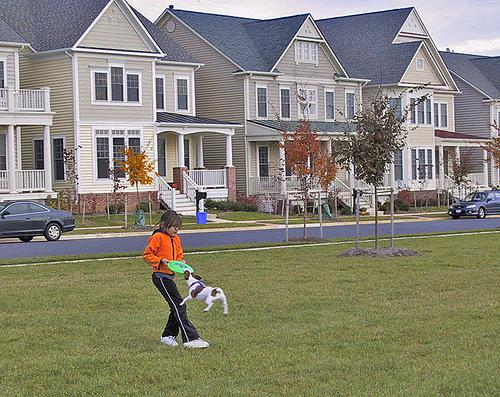Question: where are the dog and girl playing?
Choices:
A. Across the street from row houses.
B. In a field.
C. In a park.
D. Far away.
Answer with the letter. Answer: A Question: when was this image taken?
Choices:
A. Daytime.
B. Before nightfall.
C. During field day.
D. Morning or afternoon.
Answer with the letter. Answer: D Question: why is the dog jumping at this person?
Choices:
A. A ball.
B. She has a frisbee.
C. A snack.
D. A bone.
Answer with the letter. Answer: B 